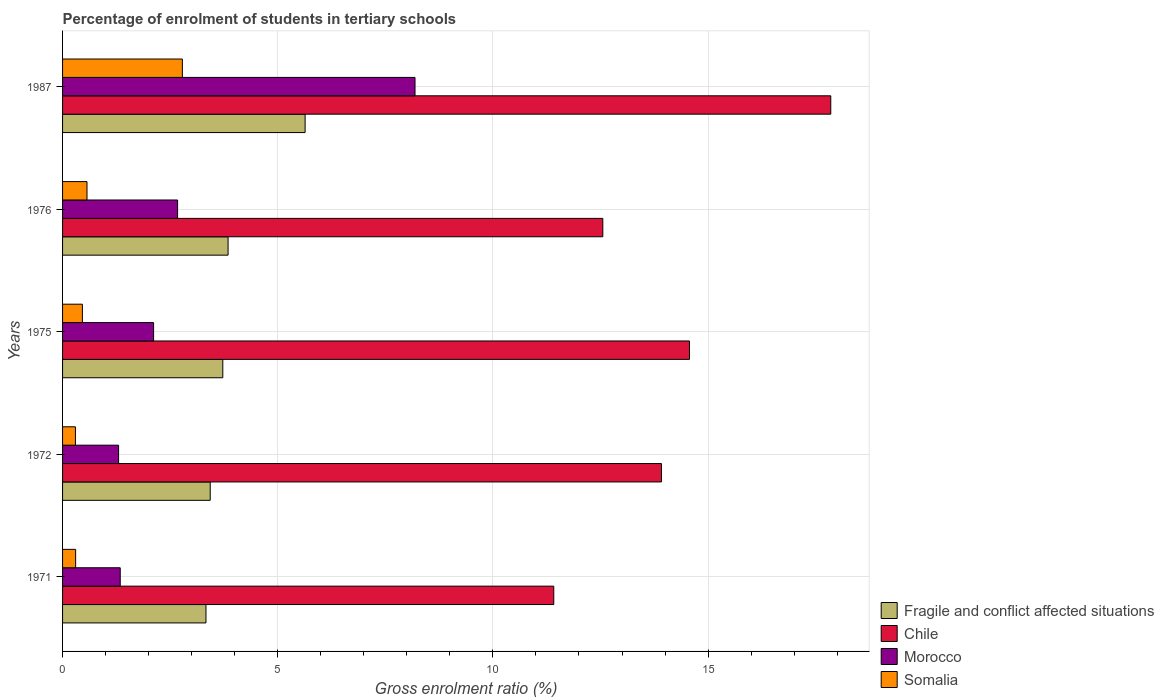How many groups of bars are there?
Make the answer very short. 5. Are the number of bars on each tick of the Y-axis equal?
Provide a succinct answer. Yes. How many bars are there on the 3rd tick from the top?
Provide a short and direct response. 4. What is the label of the 2nd group of bars from the top?
Your answer should be compact. 1976. In how many cases, is the number of bars for a given year not equal to the number of legend labels?
Offer a very short reply. 0. What is the percentage of students enrolled in tertiary schools in Fragile and conflict affected situations in 1976?
Your answer should be very brief. 3.85. Across all years, what is the maximum percentage of students enrolled in tertiary schools in Chile?
Provide a short and direct response. 17.85. Across all years, what is the minimum percentage of students enrolled in tertiary schools in Fragile and conflict affected situations?
Provide a succinct answer. 3.33. What is the total percentage of students enrolled in tertiary schools in Morocco in the graph?
Provide a succinct answer. 15.62. What is the difference between the percentage of students enrolled in tertiary schools in Chile in 1975 and that in 1976?
Your response must be concise. 2.01. What is the difference between the percentage of students enrolled in tertiary schools in Chile in 1987 and the percentage of students enrolled in tertiary schools in Somalia in 1972?
Offer a terse response. 17.55. What is the average percentage of students enrolled in tertiary schools in Chile per year?
Provide a short and direct response. 14.06. In the year 1972, what is the difference between the percentage of students enrolled in tertiary schools in Fragile and conflict affected situations and percentage of students enrolled in tertiary schools in Chile?
Provide a succinct answer. -10.49. What is the ratio of the percentage of students enrolled in tertiary schools in Chile in 1971 to that in 1987?
Your answer should be compact. 0.64. Is the percentage of students enrolled in tertiary schools in Chile in 1975 less than that in 1976?
Your response must be concise. No. Is the difference between the percentage of students enrolled in tertiary schools in Fragile and conflict affected situations in 1972 and 1975 greater than the difference between the percentage of students enrolled in tertiary schools in Chile in 1972 and 1975?
Offer a terse response. Yes. What is the difference between the highest and the second highest percentage of students enrolled in tertiary schools in Fragile and conflict affected situations?
Offer a terse response. 1.79. What is the difference between the highest and the lowest percentage of students enrolled in tertiary schools in Fragile and conflict affected situations?
Your answer should be compact. 2.3. Is it the case that in every year, the sum of the percentage of students enrolled in tertiary schools in Chile and percentage of students enrolled in tertiary schools in Fragile and conflict affected situations is greater than the sum of percentage of students enrolled in tertiary schools in Morocco and percentage of students enrolled in tertiary schools in Somalia?
Your answer should be compact. No. What does the 2nd bar from the top in 1987 represents?
Your response must be concise. Morocco. What does the 2nd bar from the bottom in 1976 represents?
Give a very brief answer. Chile. Are all the bars in the graph horizontal?
Your response must be concise. Yes. What is the difference between two consecutive major ticks on the X-axis?
Provide a short and direct response. 5. Are the values on the major ticks of X-axis written in scientific E-notation?
Keep it short and to the point. No. Does the graph contain any zero values?
Keep it short and to the point. No. Does the graph contain grids?
Your answer should be very brief. Yes. Where does the legend appear in the graph?
Your response must be concise. Bottom right. How many legend labels are there?
Offer a very short reply. 4. How are the legend labels stacked?
Offer a terse response. Vertical. What is the title of the graph?
Your answer should be very brief. Percentage of enrolment of students in tertiary schools. What is the label or title of the X-axis?
Ensure brevity in your answer.  Gross enrolment ratio (%). What is the Gross enrolment ratio (%) in Fragile and conflict affected situations in 1971?
Provide a succinct answer. 3.33. What is the Gross enrolment ratio (%) of Chile in 1971?
Provide a short and direct response. 11.41. What is the Gross enrolment ratio (%) of Morocco in 1971?
Make the answer very short. 1.34. What is the Gross enrolment ratio (%) in Somalia in 1971?
Offer a terse response. 0.3. What is the Gross enrolment ratio (%) in Fragile and conflict affected situations in 1972?
Offer a terse response. 3.43. What is the Gross enrolment ratio (%) of Chile in 1972?
Offer a very short reply. 13.92. What is the Gross enrolment ratio (%) in Morocco in 1972?
Your response must be concise. 1.3. What is the Gross enrolment ratio (%) in Somalia in 1972?
Ensure brevity in your answer.  0.3. What is the Gross enrolment ratio (%) of Fragile and conflict affected situations in 1975?
Make the answer very short. 3.72. What is the Gross enrolment ratio (%) of Chile in 1975?
Your response must be concise. 14.57. What is the Gross enrolment ratio (%) of Morocco in 1975?
Keep it short and to the point. 2.12. What is the Gross enrolment ratio (%) of Somalia in 1975?
Give a very brief answer. 0.46. What is the Gross enrolment ratio (%) of Fragile and conflict affected situations in 1976?
Offer a terse response. 3.85. What is the Gross enrolment ratio (%) in Chile in 1976?
Keep it short and to the point. 12.55. What is the Gross enrolment ratio (%) of Morocco in 1976?
Give a very brief answer. 2.67. What is the Gross enrolment ratio (%) of Somalia in 1976?
Keep it short and to the point. 0.57. What is the Gross enrolment ratio (%) of Fragile and conflict affected situations in 1987?
Your answer should be very brief. 5.64. What is the Gross enrolment ratio (%) of Chile in 1987?
Offer a very short reply. 17.85. What is the Gross enrolment ratio (%) of Morocco in 1987?
Ensure brevity in your answer.  8.19. What is the Gross enrolment ratio (%) in Somalia in 1987?
Keep it short and to the point. 2.78. Across all years, what is the maximum Gross enrolment ratio (%) of Fragile and conflict affected situations?
Provide a succinct answer. 5.64. Across all years, what is the maximum Gross enrolment ratio (%) of Chile?
Make the answer very short. 17.85. Across all years, what is the maximum Gross enrolment ratio (%) in Morocco?
Offer a terse response. 8.19. Across all years, what is the maximum Gross enrolment ratio (%) of Somalia?
Make the answer very short. 2.78. Across all years, what is the minimum Gross enrolment ratio (%) in Fragile and conflict affected situations?
Provide a succinct answer. 3.33. Across all years, what is the minimum Gross enrolment ratio (%) of Chile?
Your answer should be very brief. 11.41. Across all years, what is the minimum Gross enrolment ratio (%) of Morocco?
Offer a very short reply. 1.3. Across all years, what is the minimum Gross enrolment ratio (%) of Somalia?
Keep it short and to the point. 0.3. What is the total Gross enrolment ratio (%) in Fragile and conflict affected situations in the graph?
Offer a terse response. 19.97. What is the total Gross enrolment ratio (%) in Chile in the graph?
Provide a succinct answer. 70.3. What is the total Gross enrolment ratio (%) of Morocco in the graph?
Keep it short and to the point. 15.62. What is the total Gross enrolment ratio (%) of Somalia in the graph?
Offer a terse response. 4.42. What is the difference between the Gross enrolment ratio (%) in Fragile and conflict affected situations in 1971 and that in 1972?
Offer a very short reply. -0.1. What is the difference between the Gross enrolment ratio (%) in Chile in 1971 and that in 1972?
Ensure brevity in your answer.  -2.5. What is the difference between the Gross enrolment ratio (%) in Morocco in 1971 and that in 1972?
Your response must be concise. 0.04. What is the difference between the Gross enrolment ratio (%) of Somalia in 1971 and that in 1972?
Keep it short and to the point. 0. What is the difference between the Gross enrolment ratio (%) in Fragile and conflict affected situations in 1971 and that in 1975?
Keep it short and to the point. -0.39. What is the difference between the Gross enrolment ratio (%) of Chile in 1971 and that in 1975?
Offer a very short reply. -3.15. What is the difference between the Gross enrolment ratio (%) in Morocco in 1971 and that in 1975?
Your answer should be compact. -0.78. What is the difference between the Gross enrolment ratio (%) in Somalia in 1971 and that in 1975?
Ensure brevity in your answer.  -0.16. What is the difference between the Gross enrolment ratio (%) of Fragile and conflict affected situations in 1971 and that in 1976?
Ensure brevity in your answer.  -0.51. What is the difference between the Gross enrolment ratio (%) of Chile in 1971 and that in 1976?
Give a very brief answer. -1.14. What is the difference between the Gross enrolment ratio (%) in Morocco in 1971 and that in 1976?
Offer a very short reply. -1.33. What is the difference between the Gross enrolment ratio (%) of Somalia in 1971 and that in 1976?
Provide a short and direct response. -0.26. What is the difference between the Gross enrolment ratio (%) in Fragile and conflict affected situations in 1971 and that in 1987?
Make the answer very short. -2.3. What is the difference between the Gross enrolment ratio (%) in Chile in 1971 and that in 1987?
Your answer should be very brief. -6.44. What is the difference between the Gross enrolment ratio (%) in Morocco in 1971 and that in 1987?
Provide a succinct answer. -6.85. What is the difference between the Gross enrolment ratio (%) in Somalia in 1971 and that in 1987?
Your answer should be compact. -2.48. What is the difference between the Gross enrolment ratio (%) of Fragile and conflict affected situations in 1972 and that in 1975?
Provide a succinct answer. -0.29. What is the difference between the Gross enrolment ratio (%) of Chile in 1972 and that in 1975?
Your answer should be very brief. -0.65. What is the difference between the Gross enrolment ratio (%) in Morocco in 1972 and that in 1975?
Make the answer very short. -0.81. What is the difference between the Gross enrolment ratio (%) of Somalia in 1972 and that in 1975?
Provide a succinct answer. -0.16. What is the difference between the Gross enrolment ratio (%) of Fragile and conflict affected situations in 1972 and that in 1976?
Make the answer very short. -0.41. What is the difference between the Gross enrolment ratio (%) in Chile in 1972 and that in 1976?
Give a very brief answer. 1.36. What is the difference between the Gross enrolment ratio (%) of Morocco in 1972 and that in 1976?
Ensure brevity in your answer.  -1.37. What is the difference between the Gross enrolment ratio (%) of Somalia in 1972 and that in 1976?
Your response must be concise. -0.27. What is the difference between the Gross enrolment ratio (%) in Fragile and conflict affected situations in 1972 and that in 1987?
Keep it short and to the point. -2.21. What is the difference between the Gross enrolment ratio (%) of Chile in 1972 and that in 1987?
Your response must be concise. -3.93. What is the difference between the Gross enrolment ratio (%) of Morocco in 1972 and that in 1987?
Give a very brief answer. -6.89. What is the difference between the Gross enrolment ratio (%) in Somalia in 1972 and that in 1987?
Your answer should be very brief. -2.48. What is the difference between the Gross enrolment ratio (%) in Fragile and conflict affected situations in 1975 and that in 1976?
Offer a terse response. -0.12. What is the difference between the Gross enrolment ratio (%) of Chile in 1975 and that in 1976?
Your answer should be compact. 2.01. What is the difference between the Gross enrolment ratio (%) of Morocco in 1975 and that in 1976?
Keep it short and to the point. -0.56. What is the difference between the Gross enrolment ratio (%) in Somalia in 1975 and that in 1976?
Provide a succinct answer. -0.11. What is the difference between the Gross enrolment ratio (%) in Fragile and conflict affected situations in 1975 and that in 1987?
Your answer should be compact. -1.91. What is the difference between the Gross enrolment ratio (%) in Chile in 1975 and that in 1987?
Provide a short and direct response. -3.28. What is the difference between the Gross enrolment ratio (%) in Morocco in 1975 and that in 1987?
Keep it short and to the point. -6.07. What is the difference between the Gross enrolment ratio (%) in Somalia in 1975 and that in 1987?
Your response must be concise. -2.32. What is the difference between the Gross enrolment ratio (%) in Fragile and conflict affected situations in 1976 and that in 1987?
Your response must be concise. -1.79. What is the difference between the Gross enrolment ratio (%) in Chile in 1976 and that in 1987?
Give a very brief answer. -5.3. What is the difference between the Gross enrolment ratio (%) in Morocco in 1976 and that in 1987?
Offer a very short reply. -5.52. What is the difference between the Gross enrolment ratio (%) of Somalia in 1976 and that in 1987?
Ensure brevity in your answer.  -2.22. What is the difference between the Gross enrolment ratio (%) in Fragile and conflict affected situations in 1971 and the Gross enrolment ratio (%) in Chile in 1972?
Offer a very short reply. -10.58. What is the difference between the Gross enrolment ratio (%) of Fragile and conflict affected situations in 1971 and the Gross enrolment ratio (%) of Morocco in 1972?
Offer a terse response. 2.03. What is the difference between the Gross enrolment ratio (%) in Fragile and conflict affected situations in 1971 and the Gross enrolment ratio (%) in Somalia in 1972?
Offer a terse response. 3.03. What is the difference between the Gross enrolment ratio (%) in Chile in 1971 and the Gross enrolment ratio (%) in Morocco in 1972?
Make the answer very short. 10.11. What is the difference between the Gross enrolment ratio (%) of Chile in 1971 and the Gross enrolment ratio (%) of Somalia in 1972?
Ensure brevity in your answer.  11.12. What is the difference between the Gross enrolment ratio (%) in Morocco in 1971 and the Gross enrolment ratio (%) in Somalia in 1972?
Give a very brief answer. 1.04. What is the difference between the Gross enrolment ratio (%) in Fragile and conflict affected situations in 1971 and the Gross enrolment ratio (%) in Chile in 1975?
Provide a short and direct response. -11.24. What is the difference between the Gross enrolment ratio (%) of Fragile and conflict affected situations in 1971 and the Gross enrolment ratio (%) of Morocco in 1975?
Your answer should be compact. 1.22. What is the difference between the Gross enrolment ratio (%) in Fragile and conflict affected situations in 1971 and the Gross enrolment ratio (%) in Somalia in 1975?
Provide a succinct answer. 2.87. What is the difference between the Gross enrolment ratio (%) in Chile in 1971 and the Gross enrolment ratio (%) in Morocco in 1975?
Keep it short and to the point. 9.3. What is the difference between the Gross enrolment ratio (%) in Chile in 1971 and the Gross enrolment ratio (%) in Somalia in 1975?
Provide a short and direct response. 10.95. What is the difference between the Gross enrolment ratio (%) of Morocco in 1971 and the Gross enrolment ratio (%) of Somalia in 1975?
Keep it short and to the point. 0.88. What is the difference between the Gross enrolment ratio (%) in Fragile and conflict affected situations in 1971 and the Gross enrolment ratio (%) in Chile in 1976?
Your answer should be very brief. -9.22. What is the difference between the Gross enrolment ratio (%) in Fragile and conflict affected situations in 1971 and the Gross enrolment ratio (%) in Morocco in 1976?
Ensure brevity in your answer.  0.66. What is the difference between the Gross enrolment ratio (%) of Fragile and conflict affected situations in 1971 and the Gross enrolment ratio (%) of Somalia in 1976?
Offer a terse response. 2.76. What is the difference between the Gross enrolment ratio (%) in Chile in 1971 and the Gross enrolment ratio (%) in Morocco in 1976?
Make the answer very short. 8.74. What is the difference between the Gross enrolment ratio (%) in Chile in 1971 and the Gross enrolment ratio (%) in Somalia in 1976?
Provide a succinct answer. 10.85. What is the difference between the Gross enrolment ratio (%) in Morocco in 1971 and the Gross enrolment ratio (%) in Somalia in 1976?
Ensure brevity in your answer.  0.77. What is the difference between the Gross enrolment ratio (%) in Fragile and conflict affected situations in 1971 and the Gross enrolment ratio (%) in Chile in 1987?
Offer a terse response. -14.52. What is the difference between the Gross enrolment ratio (%) of Fragile and conflict affected situations in 1971 and the Gross enrolment ratio (%) of Morocco in 1987?
Your answer should be compact. -4.86. What is the difference between the Gross enrolment ratio (%) in Fragile and conflict affected situations in 1971 and the Gross enrolment ratio (%) in Somalia in 1987?
Your response must be concise. 0.55. What is the difference between the Gross enrolment ratio (%) of Chile in 1971 and the Gross enrolment ratio (%) of Morocco in 1987?
Your answer should be compact. 3.22. What is the difference between the Gross enrolment ratio (%) of Chile in 1971 and the Gross enrolment ratio (%) of Somalia in 1987?
Provide a succinct answer. 8.63. What is the difference between the Gross enrolment ratio (%) of Morocco in 1971 and the Gross enrolment ratio (%) of Somalia in 1987?
Provide a succinct answer. -1.44. What is the difference between the Gross enrolment ratio (%) in Fragile and conflict affected situations in 1972 and the Gross enrolment ratio (%) in Chile in 1975?
Your answer should be compact. -11.14. What is the difference between the Gross enrolment ratio (%) of Fragile and conflict affected situations in 1972 and the Gross enrolment ratio (%) of Morocco in 1975?
Provide a short and direct response. 1.32. What is the difference between the Gross enrolment ratio (%) in Fragile and conflict affected situations in 1972 and the Gross enrolment ratio (%) in Somalia in 1975?
Give a very brief answer. 2.97. What is the difference between the Gross enrolment ratio (%) of Chile in 1972 and the Gross enrolment ratio (%) of Morocco in 1975?
Provide a short and direct response. 11.8. What is the difference between the Gross enrolment ratio (%) in Chile in 1972 and the Gross enrolment ratio (%) in Somalia in 1975?
Provide a succinct answer. 13.46. What is the difference between the Gross enrolment ratio (%) of Morocco in 1972 and the Gross enrolment ratio (%) of Somalia in 1975?
Provide a short and direct response. 0.84. What is the difference between the Gross enrolment ratio (%) in Fragile and conflict affected situations in 1972 and the Gross enrolment ratio (%) in Chile in 1976?
Give a very brief answer. -9.12. What is the difference between the Gross enrolment ratio (%) of Fragile and conflict affected situations in 1972 and the Gross enrolment ratio (%) of Morocco in 1976?
Your answer should be compact. 0.76. What is the difference between the Gross enrolment ratio (%) of Fragile and conflict affected situations in 1972 and the Gross enrolment ratio (%) of Somalia in 1976?
Provide a succinct answer. 2.86. What is the difference between the Gross enrolment ratio (%) in Chile in 1972 and the Gross enrolment ratio (%) in Morocco in 1976?
Your answer should be compact. 11.24. What is the difference between the Gross enrolment ratio (%) in Chile in 1972 and the Gross enrolment ratio (%) in Somalia in 1976?
Keep it short and to the point. 13.35. What is the difference between the Gross enrolment ratio (%) of Morocco in 1972 and the Gross enrolment ratio (%) of Somalia in 1976?
Ensure brevity in your answer.  0.73. What is the difference between the Gross enrolment ratio (%) of Fragile and conflict affected situations in 1972 and the Gross enrolment ratio (%) of Chile in 1987?
Make the answer very short. -14.42. What is the difference between the Gross enrolment ratio (%) of Fragile and conflict affected situations in 1972 and the Gross enrolment ratio (%) of Morocco in 1987?
Your answer should be very brief. -4.76. What is the difference between the Gross enrolment ratio (%) in Fragile and conflict affected situations in 1972 and the Gross enrolment ratio (%) in Somalia in 1987?
Give a very brief answer. 0.65. What is the difference between the Gross enrolment ratio (%) in Chile in 1972 and the Gross enrolment ratio (%) in Morocco in 1987?
Keep it short and to the point. 5.73. What is the difference between the Gross enrolment ratio (%) in Chile in 1972 and the Gross enrolment ratio (%) in Somalia in 1987?
Keep it short and to the point. 11.13. What is the difference between the Gross enrolment ratio (%) in Morocco in 1972 and the Gross enrolment ratio (%) in Somalia in 1987?
Offer a terse response. -1.48. What is the difference between the Gross enrolment ratio (%) in Fragile and conflict affected situations in 1975 and the Gross enrolment ratio (%) in Chile in 1976?
Your answer should be compact. -8.83. What is the difference between the Gross enrolment ratio (%) of Fragile and conflict affected situations in 1975 and the Gross enrolment ratio (%) of Morocco in 1976?
Ensure brevity in your answer.  1.05. What is the difference between the Gross enrolment ratio (%) of Fragile and conflict affected situations in 1975 and the Gross enrolment ratio (%) of Somalia in 1976?
Provide a short and direct response. 3.16. What is the difference between the Gross enrolment ratio (%) in Chile in 1975 and the Gross enrolment ratio (%) in Morocco in 1976?
Give a very brief answer. 11.9. What is the difference between the Gross enrolment ratio (%) in Chile in 1975 and the Gross enrolment ratio (%) in Somalia in 1976?
Your answer should be compact. 14. What is the difference between the Gross enrolment ratio (%) of Morocco in 1975 and the Gross enrolment ratio (%) of Somalia in 1976?
Your answer should be very brief. 1.55. What is the difference between the Gross enrolment ratio (%) of Fragile and conflict affected situations in 1975 and the Gross enrolment ratio (%) of Chile in 1987?
Offer a terse response. -14.13. What is the difference between the Gross enrolment ratio (%) in Fragile and conflict affected situations in 1975 and the Gross enrolment ratio (%) in Morocco in 1987?
Provide a succinct answer. -4.47. What is the difference between the Gross enrolment ratio (%) in Fragile and conflict affected situations in 1975 and the Gross enrolment ratio (%) in Somalia in 1987?
Offer a terse response. 0.94. What is the difference between the Gross enrolment ratio (%) in Chile in 1975 and the Gross enrolment ratio (%) in Morocco in 1987?
Your answer should be compact. 6.38. What is the difference between the Gross enrolment ratio (%) of Chile in 1975 and the Gross enrolment ratio (%) of Somalia in 1987?
Your answer should be compact. 11.78. What is the difference between the Gross enrolment ratio (%) in Morocco in 1975 and the Gross enrolment ratio (%) in Somalia in 1987?
Your answer should be compact. -0.67. What is the difference between the Gross enrolment ratio (%) of Fragile and conflict affected situations in 1976 and the Gross enrolment ratio (%) of Chile in 1987?
Your answer should be compact. -14.01. What is the difference between the Gross enrolment ratio (%) in Fragile and conflict affected situations in 1976 and the Gross enrolment ratio (%) in Morocco in 1987?
Give a very brief answer. -4.34. What is the difference between the Gross enrolment ratio (%) in Fragile and conflict affected situations in 1976 and the Gross enrolment ratio (%) in Somalia in 1987?
Make the answer very short. 1.06. What is the difference between the Gross enrolment ratio (%) of Chile in 1976 and the Gross enrolment ratio (%) of Morocco in 1987?
Make the answer very short. 4.36. What is the difference between the Gross enrolment ratio (%) of Chile in 1976 and the Gross enrolment ratio (%) of Somalia in 1987?
Your answer should be compact. 9.77. What is the difference between the Gross enrolment ratio (%) in Morocco in 1976 and the Gross enrolment ratio (%) in Somalia in 1987?
Offer a terse response. -0.11. What is the average Gross enrolment ratio (%) of Fragile and conflict affected situations per year?
Give a very brief answer. 3.99. What is the average Gross enrolment ratio (%) in Chile per year?
Give a very brief answer. 14.06. What is the average Gross enrolment ratio (%) of Morocco per year?
Offer a very short reply. 3.12. What is the average Gross enrolment ratio (%) of Somalia per year?
Make the answer very short. 0.88. In the year 1971, what is the difference between the Gross enrolment ratio (%) of Fragile and conflict affected situations and Gross enrolment ratio (%) of Chile?
Offer a terse response. -8.08. In the year 1971, what is the difference between the Gross enrolment ratio (%) in Fragile and conflict affected situations and Gross enrolment ratio (%) in Morocco?
Your answer should be very brief. 1.99. In the year 1971, what is the difference between the Gross enrolment ratio (%) in Fragile and conflict affected situations and Gross enrolment ratio (%) in Somalia?
Offer a terse response. 3.03. In the year 1971, what is the difference between the Gross enrolment ratio (%) of Chile and Gross enrolment ratio (%) of Morocco?
Provide a short and direct response. 10.07. In the year 1971, what is the difference between the Gross enrolment ratio (%) in Chile and Gross enrolment ratio (%) in Somalia?
Keep it short and to the point. 11.11. In the year 1971, what is the difference between the Gross enrolment ratio (%) of Morocco and Gross enrolment ratio (%) of Somalia?
Make the answer very short. 1.04. In the year 1972, what is the difference between the Gross enrolment ratio (%) in Fragile and conflict affected situations and Gross enrolment ratio (%) in Chile?
Keep it short and to the point. -10.49. In the year 1972, what is the difference between the Gross enrolment ratio (%) of Fragile and conflict affected situations and Gross enrolment ratio (%) of Morocco?
Give a very brief answer. 2.13. In the year 1972, what is the difference between the Gross enrolment ratio (%) of Fragile and conflict affected situations and Gross enrolment ratio (%) of Somalia?
Your answer should be very brief. 3.13. In the year 1972, what is the difference between the Gross enrolment ratio (%) in Chile and Gross enrolment ratio (%) in Morocco?
Make the answer very short. 12.61. In the year 1972, what is the difference between the Gross enrolment ratio (%) of Chile and Gross enrolment ratio (%) of Somalia?
Provide a short and direct response. 13.62. In the year 1972, what is the difference between the Gross enrolment ratio (%) of Morocco and Gross enrolment ratio (%) of Somalia?
Keep it short and to the point. 1. In the year 1975, what is the difference between the Gross enrolment ratio (%) of Fragile and conflict affected situations and Gross enrolment ratio (%) of Chile?
Keep it short and to the point. -10.84. In the year 1975, what is the difference between the Gross enrolment ratio (%) in Fragile and conflict affected situations and Gross enrolment ratio (%) in Morocco?
Your answer should be compact. 1.61. In the year 1975, what is the difference between the Gross enrolment ratio (%) in Fragile and conflict affected situations and Gross enrolment ratio (%) in Somalia?
Offer a very short reply. 3.26. In the year 1975, what is the difference between the Gross enrolment ratio (%) in Chile and Gross enrolment ratio (%) in Morocco?
Offer a very short reply. 12.45. In the year 1975, what is the difference between the Gross enrolment ratio (%) of Chile and Gross enrolment ratio (%) of Somalia?
Provide a short and direct response. 14.11. In the year 1975, what is the difference between the Gross enrolment ratio (%) in Morocco and Gross enrolment ratio (%) in Somalia?
Keep it short and to the point. 1.65. In the year 1976, what is the difference between the Gross enrolment ratio (%) of Fragile and conflict affected situations and Gross enrolment ratio (%) of Chile?
Give a very brief answer. -8.71. In the year 1976, what is the difference between the Gross enrolment ratio (%) of Fragile and conflict affected situations and Gross enrolment ratio (%) of Morocco?
Your response must be concise. 1.17. In the year 1976, what is the difference between the Gross enrolment ratio (%) in Fragile and conflict affected situations and Gross enrolment ratio (%) in Somalia?
Provide a short and direct response. 3.28. In the year 1976, what is the difference between the Gross enrolment ratio (%) of Chile and Gross enrolment ratio (%) of Morocco?
Make the answer very short. 9.88. In the year 1976, what is the difference between the Gross enrolment ratio (%) in Chile and Gross enrolment ratio (%) in Somalia?
Your response must be concise. 11.99. In the year 1976, what is the difference between the Gross enrolment ratio (%) in Morocco and Gross enrolment ratio (%) in Somalia?
Your answer should be compact. 2.11. In the year 1987, what is the difference between the Gross enrolment ratio (%) of Fragile and conflict affected situations and Gross enrolment ratio (%) of Chile?
Offer a very short reply. -12.22. In the year 1987, what is the difference between the Gross enrolment ratio (%) of Fragile and conflict affected situations and Gross enrolment ratio (%) of Morocco?
Offer a terse response. -2.55. In the year 1987, what is the difference between the Gross enrolment ratio (%) in Fragile and conflict affected situations and Gross enrolment ratio (%) in Somalia?
Make the answer very short. 2.85. In the year 1987, what is the difference between the Gross enrolment ratio (%) in Chile and Gross enrolment ratio (%) in Morocco?
Keep it short and to the point. 9.66. In the year 1987, what is the difference between the Gross enrolment ratio (%) in Chile and Gross enrolment ratio (%) in Somalia?
Your answer should be compact. 15.07. In the year 1987, what is the difference between the Gross enrolment ratio (%) in Morocco and Gross enrolment ratio (%) in Somalia?
Keep it short and to the point. 5.41. What is the ratio of the Gross enrolment ratio (%) in Fragile and conflict affected situations in 1971 to that in 1972?
Offer a terse response. 0.97. What is the ratio of the Gross enrolment ratio (%) of Chile in 1971 to that in 1972?
Give a very brief answer. 0.82. What is the ratio of the Gross enrolment ratio (%) of Morocco in 1971 to that in 1972?
Ensure brevity in your answer.  1.03. What is the ratio of the Gross enrolment ratio (%) of Somalia in 1971 to that in 1972?
Your answer should be very brief. 1.02. What is the ratio of the Gross enrolment ratio (%) of Fragile and conflict affected situations in 1971 to that in 1975?
Your response must be concise. 0.9. What is the ratio of the Gross enrolment ratio (%) of Chile in 1971 to that in 1975?
Provide a short and direct response. 0.78. What is the ratio of the Gross enrolment ratio (%) of Morocco in 1971 to that in 1975?
Provide a short and direct response. 0.63. What is the ratio of the Gross enrolment ratio (%) of Somalia in 1971 to that in 1975?
Provide a short and direct response. 0.66. What is the ratio of the Gross enrolment ratio (%) in Fragile and conflict affected situations in 1971 to that in 1976?
Give a very brief answer. 0.87. What is the ratio of the Gross enrolment ratio (%) of Chile in 1971 to that in 1976?
Give a very brief answer. 0.91. What is the ratio of the Gross enrolment ratio (%) of Morocco in 1971 to that in 1976?
Make the answer very short. 0.5. What is the ratio of the Gross enrolment ratio (%) in Somalia in 1971 to that in 1976?
Provide a succinct answer. 0.54. What is the ratio of the Gross enrolment ratio (%) in Fragile and conflict affected situations in 1971 to that in 1987?
Make the answer very short. 0.59. What is the ratio of the Gross enrolment ratio (%) of Chile in 1971 to that in 1987?
Offer a very short reply. 0.64. What is the ratio of the Gross enrolment ratio (%) in Morocco in 1971 to that in 1987?
Offer a very short reply. 0.16. What is the ratio of the Gross enrolment ratio (%) of Somalia in 1971 to that in 1987?
Make the answer very short. 0.11. What is the ratio of the Gross enrolment ratio (%) of Fragile and conflict affected situations in 1972 to that in 1975?
Your answer should be very brief. 0.92. What is the ratio of the Gross enrolment ratio (%) in Chile in 1972 to that in 1975?
Make the answer very short. 0.96. What is the ratio of the Gross enrolment ratio (%) of Morocco in 1972 to that in 1975?
Your response must be concise. 0.62. What is the ratio of the Gross enrolment ratio (%) of Somalia in 1972 to that in 1975?
Your answer should be compact. 0.65. What is the ratio of the Gross enrolment ratio (%) of Fragile and conflict affected situations in 1972 to that in 1976?
Give a very brief answer. 0.89. What is the ratio of the Gross enrolment ratio (%) of Chile in 1972 to that in 1976?
Your answer should be compact. 1.11. What is the ratio of the Gross enrolment ratio (%) of Morocco in 1972 to that in 1976?
Make the answer very short. 0.49. What is the ratio of the Gross enrolment ratio (%) in Somalia in 1972 to that in 1976?
Provide a succinct answer. 0.53. What is the ratio of the Gross enrolment ratio (%) of Fragile and conflict affected situations in 1972 to that in 1987?
Offer a terse response. 0.61. What is the ratio of the Gross enrolment ratio (%) of Chile in 1972 to that in 1987?
Make the answer very short. 0.78. What is the ratio of the Gross enrolment ratio (%) in Morocco in 1972 to that in 1987?
Your response must be concise. 0.16. What is the ratio of the Gross enrolment ratio (%) in Somalia in 1972 to that in 1987?
Provide a short and direct response. 0.11. What is the ratio of the Gross enrolment ratio (%) of Fragile and conflict affected situations in 1975 to that in 1976?
Offer a terse response. 0.97. What is the ratio of the Gross enrolment ratio (%) in Chile in 1975 to that in 1976?
Offer a terse response. 1.16. What is the ratio of the Gross enrolment ratio (%) of Morocco in 1975 to that in 1976?
Make the answer very short. 0.79. What is the ratio of the Gross enrolment ratio (%) in Somalia in 1975 to that in 1976?
Make the answer very short. 0.81. What is the ratio of the Gross enrolment ratio (%) in Fragile and conflict affected situations in 1975 to that in 1987?
Provide a short and direct response. 0.66. What is the ratio of the Gross enrolment ratio (%) of Chile in 1975 to that in 1987?
Provide a short and direct response. 0.82. What is the ratio of the Gross enrolment ratio (%) in Morocco in 1975 to that in 1987?
Ensure brevity in your answer.  0.26. What is the ratio of the Gross enrolment ratio (%) in Somalia in 1975 to that in 1987?
Make the answer very short. 0.17. What is the ratio of the Gross enrolment ratio (%) of Fragile and conflict affected situations in 1976 to that in 1987?
Provide a succinct answer. 0.68. What is the ratio of the Gross enrolment ratio (%) in Chile in 1976 to that in 1987?
Give a very brief answer. 0.7. What is the ratio of the Gross enrolment ratio (%) of Morocco in 1976 to that in 1987?
Keep it short and to the point. 0.33. What is the ratio of the Gross enrolment ratio (%) in Somalia in 1976 to that in 1987?
Ensure brevity in your answer.  0.2. What is the difference between the highest and the second highest Gross enrolment ratio (%) in Fragile and conflict affected situations?
Your response must be concise. 1.79. What is the difference between the highest and the second highest Gross enrolment ratio (%) in Chile?
Make the answer very short. 3.28. What is the difference between the highest and the second highest Gross enrolment ratio (%) in Morocco?
Keep it short and to the point. 5.52. What is the difference between the highest and the second highest Gross enrolment ratio (%) of Somalia?
Offer a terse response. 2.22. What is the difference between the highest and the lowest Gross enrolment ratio (%) of Fragile and conflict affected situations?
Offer a very short reply. 2.3. What is the difference between the highest and the lowest Gross enrolment ratio (%) of Chile?
Your response must be concise. 6.44. What is the difference between the highest and the lowest Gross enrolment ratio (%) in Morocco?
Provide a short and direct response. 6.89. What is the difference between the highest and the lowest Gross enrolment ratio (%) of Somalia?
Offer a very short reply. 2.48. 